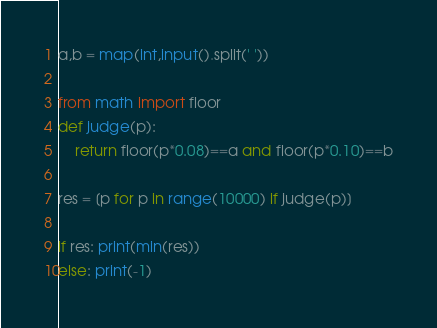Convert code to text. <code><loc_0><loc_0><loc_500><loc_500><_Python_>a,b = map(int,input().split(' '))

from math import floor
def judge(p):
    return floor(p*0.08)==a and floor(p*0.10)==b

res = [p for p in range(10000) if judge(p)]

if res: print(min(res))
else: print(-1)
</code> 